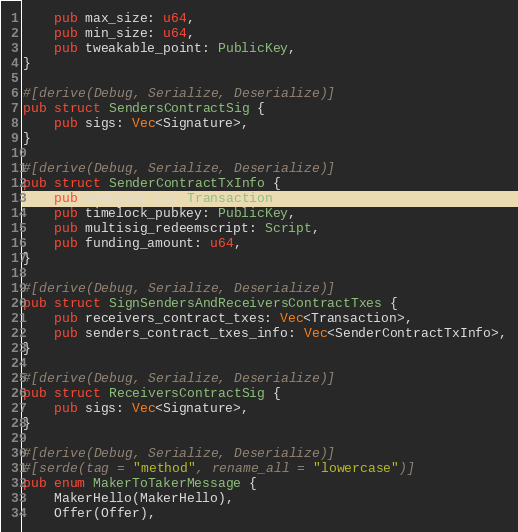<code> <loc_0><loc_0><loc_500><loc_500><_Rust_>    pub max_size: u64,
    pub min_size: u64,
    pub tweakable_point: PublicKey,
}

#[derive(Debug, Serialize, Deserialize)]
pub struct SendersContractSig {
    pub sigs: Vec<Signature>,
}

#[derive(Debug, Serialize, Deserialize)]
pub struct SenderContractTxInfo {
    pub contract_tx: Transaction,
    pub timelock_pubkey: PublicKey,
    pub multisig_redeemscript: Script,
    pub funding_amount: u64,
}

#[derive(Debug, Serialize, Deserialize)]
pub struct SignSendersAndReceiversContractTxes {
    pub receivers_contract_txes: Vec<Transaction>,
    pub senders_contract_txes_info: Vec<SenderContractTxInfo>,
}

#[derive(Debug, Serialize, Deserialize)]
pub struct ReceiversContractSig {
    pub sigs: Vec<Signature>,
}

#[derive(Debug, Serialize, Deserialize)]
#[serde(tag = "method", rename_all = "lowercase")]
pub enum MakerToTakerMessage {
    MakerHello(MakerHello),
    Offer(Offer),</code> 